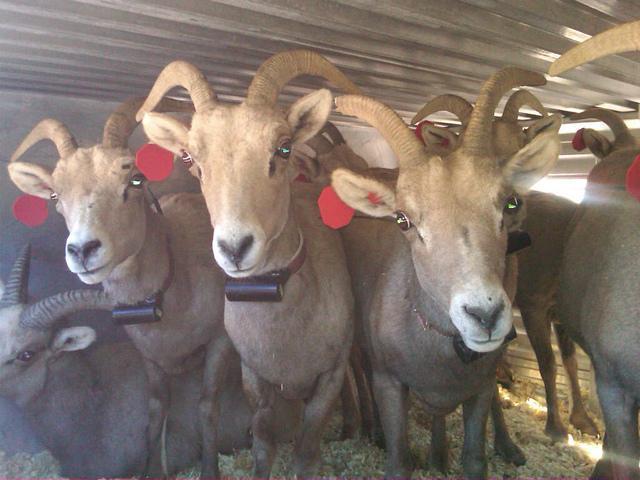What type of loose material is strewn on the floor where the animals are standing?
Choose the right answer and clarify with the format: 'Answer: answer
Rationale: rationale.'
Options: Sawdust, grain, leaves, straw. Answer: sawdust.
Rationale: Sawdust is usually strewn on the ground in barns. 